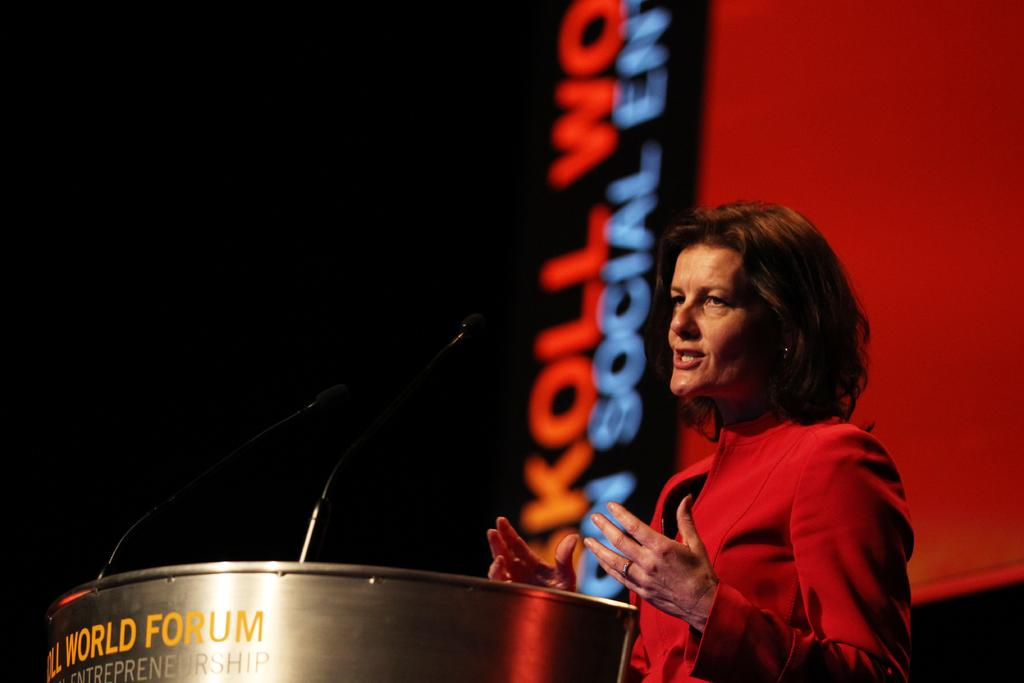Who is present in the image? There is a woman in the image. What is the woman doing in the image? The woman is standing and talking. What object is associated with the woman's activity in the image? There is a microphone in the image. What type of cake is being served to the woman's friends in the image? There is no cake or friends present in the image. 